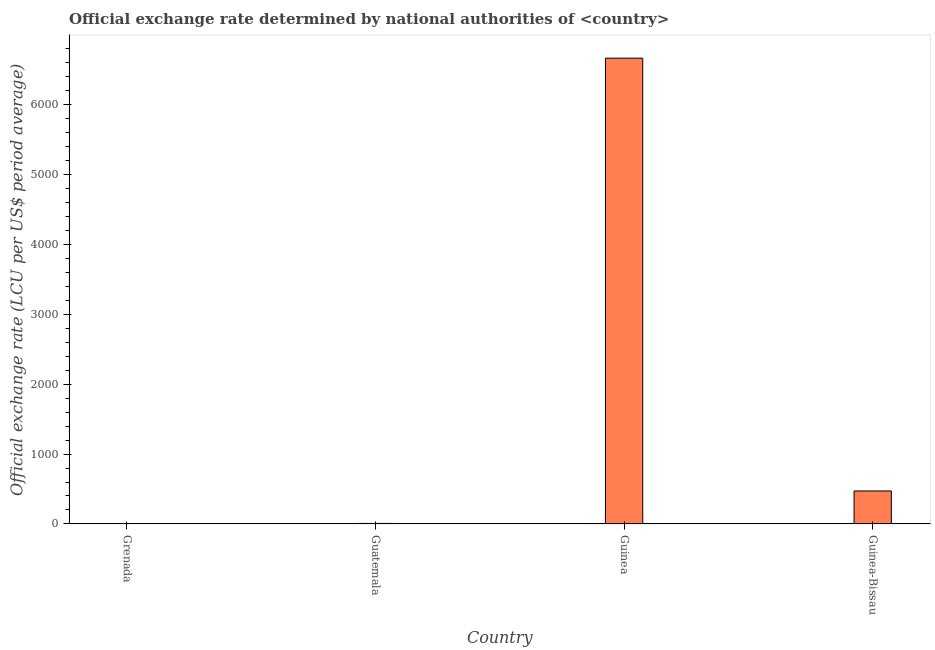Does the graph contain any zero values?
Your answer should be compact. No. Does the graph contain grids?
Provide a short and direct response. No. What is the title of the graph?
Your response must be concise. Official exchange rate determined by national authorities of <country>. What is the label or title of the X-axis?
Provide a short and direct response. Country. What is the label or title of the Y-axis?
Ensure brevity in your answer.  Official exchange rate (LCU per US$ period average). What is the official exchange rate in Guatemala?
Ensure brevity in your answer.  7.79. Across all countries, what is the maximum official exchange rate?
Your answer should be very brief. 6658.03. In which country was the official exchange rate maximum?
Make the answer very short. Guinea. In which country was the official exchange rate minimum?
Make the answer very short. Grenada. What is the sum of the official exchange rate?
Ensure brevity in your answer.  7140.38. What is the difference between the official exchange rate in Guatemala and Guinea?
Offer a very short reply. -6650.25. What is the average official exchange rate per country?
Make the answer very short. 1785.1. What is the median official exchange rate?
Keep it short and to the point. 239.83. In how many countries, is the official exchange rate greater than 1000 ?
Ensure brevity in your answer.  1. What is the ratio of the official exchange rate in Grenada to that in Guinea-Bissau?
Provide a succinct answer. 0.01. What is the difference between the highest and the second highest official exchange rate?
Your answer should be compact. 6186.16. Is the sum of the official exchange rate in Grenada and Guinea greater than the maximum official exchange rate across all countries?
Provide a short and direct response. Yes. What is the difference between the highest and the lowest official exchange rate?
Your answer should be compact. 6655.33. In how many countries, is the official exchange rate greater than the average official exchange rate taken over all countries?
Keep it short and to the point. 1. How many bars are there?
Offer a terse response. 4. Are all the bars in the graph horizontal?
Ensure brevity in your answer.  No. How many countries are there in the graph?
Your response must be concise. 4. Are the values on the major ticks of Y-axis written in scientific E-notation?
Provide a succinct answer. No. What is the Official exchange rate (LCU per US$ period average) of Grenada?
Offer a terse response. 2.7. What is the Official exchange rate (LCU per US$ period average) of Guatemala?
Offer a terse response. 7.79. What is the Official exchange rate (LCU per US$ period average) of Guinea?
Provide a short and direct response. 6658.03. What is the Official exchange rate (LCU per US$ period average) in Guinea-Bissau?
Provide a short and direct response. 471.87. What is the difference between the Official exchange rate (LCU per US$ period average) in Grenada and Guatemala?
Make the answer very short. -5.09. What is the difference between the Official exchange rate (LCU per US$ period average) in Grenada and Guinea?
Your response must be concise. -6655.33. What is the difference between the Official exchange rate (LCU per US$ period average) in Grenada and Guinea-Bissau?
Offer a terse response. -469.17. What is the difference between the Official exchange rate (LCU per US$ period average) in Guatemala and Guinea?
Your answer should be compact. -6650.25. What is the difference between the Official exchange rate (LCU per US$ period average) in Guatemala and Guinea-Bissau?
Your response must be concise. -464.08. What is the difference between the Official exchange rate (LCU per US$ period average) in Guinea and Guinea-Bissau?
Provide a succinct answer. 6186.17. What is the ratio of the Official exchange rate (LCU per US$ period average) in Grenada to that in Guatemala?
Offer a very short reply. 0.35. What is the ratio of the Official exchange rate (LCU per US$ period average) in Grenada to that in Guinea?
Provide a short and direct response. 0. What is the ratio of the Official exchange rate (LCU per US$ period average) in Grenada to that in Guinea-Bissau?
Your response must be concise. 0.01. What is the ratio of the Official exchange rate (LCU per US$ period average) in Guatemala to that in Guinea-Bissau?
Provide a short and direct response. 0.02. What is the ratio of the Official exchange rate (LCU per US$ period average) in Guinea to that in Guinea-Bissau?
Your answer should be very brief. 14.11. 